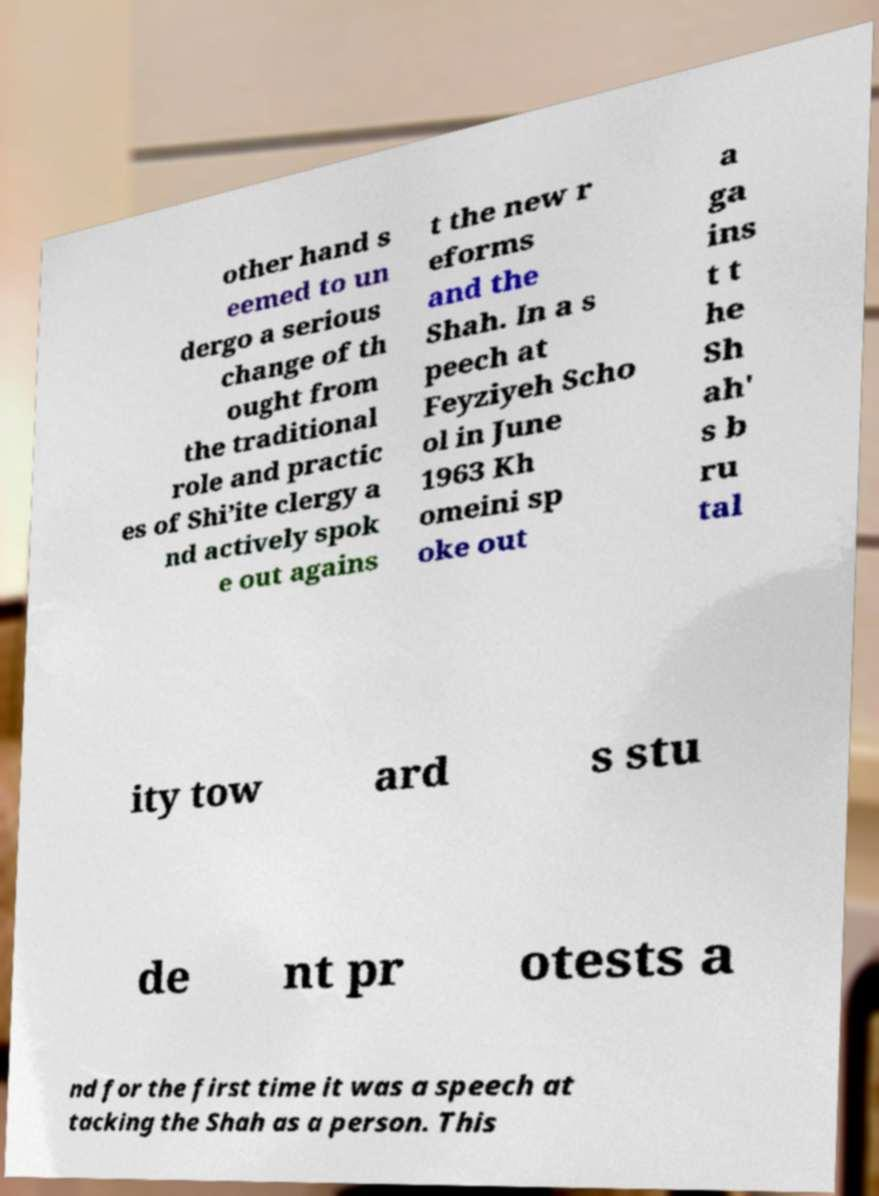Could you assist in decoding the text presented in this image and type it out clearly? other hand s eemed to un dergo a serious change of th ought from the traditional role and practic es of Shi’ite clergy a nd actively spok e out agains t the new r eforms and the Shah. In a s peech at Feyziyeh Scho ol in June 1963 Kh omeini sp oke out a ga ins t t he Sh ah' s b ru tal ity tow ard s stu de nt pr otests a nd for the first time it was a speech at tacking the Shah as a person. This 